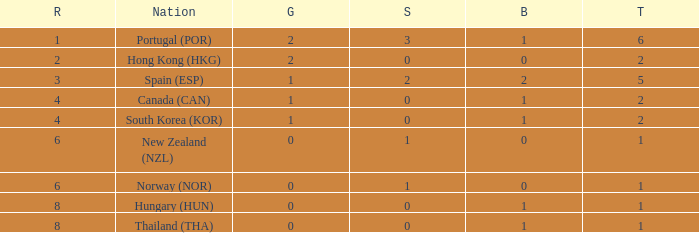Which Rank number has a Silver of 0, Gold of 2 and total smaller than 2? 0.0. 